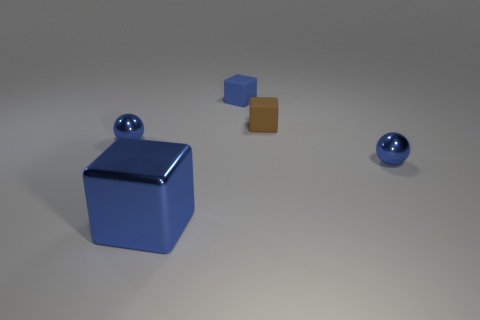Subtract all purple balls. How many blue blocks are left? 2 Subtract all tiny blocks. How many blocks are left? 1 Subtract all balls. How many objects are left? 3 Add 1 tiny balls. How many objects exist? 6 Add 4 small purple shiny cylinders. How many small purple shiny cylinders exist? 4 Subtract 0 purple cylinders. How many objects are left? 5 Subtract all tiny red shiny spheres. Subtract all tiny blue matte objects. How many objects are left? 4 Add 4 spheres. How many spheres are left? 6 